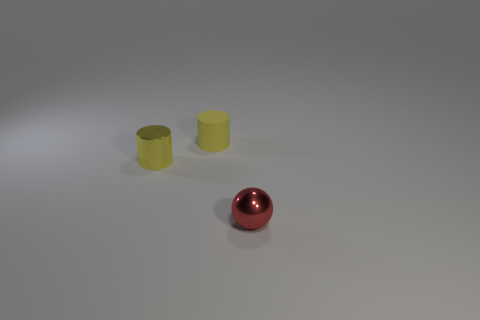Add 3 big cyan metallic things. How many objects exist? 6 Subtract all yellow metallic objects. Subtract all tiny blue metal objects. How many objects are left? 2 Add 1 spheres. How many spheres are left? 2 Add 1 tiny blue metal cylinders. How many tiny blue metal cylinders exist? 1 Subtract 1 red balls. How many objects are left? 2 Subtract all cylinders. How many objects are left? 1 